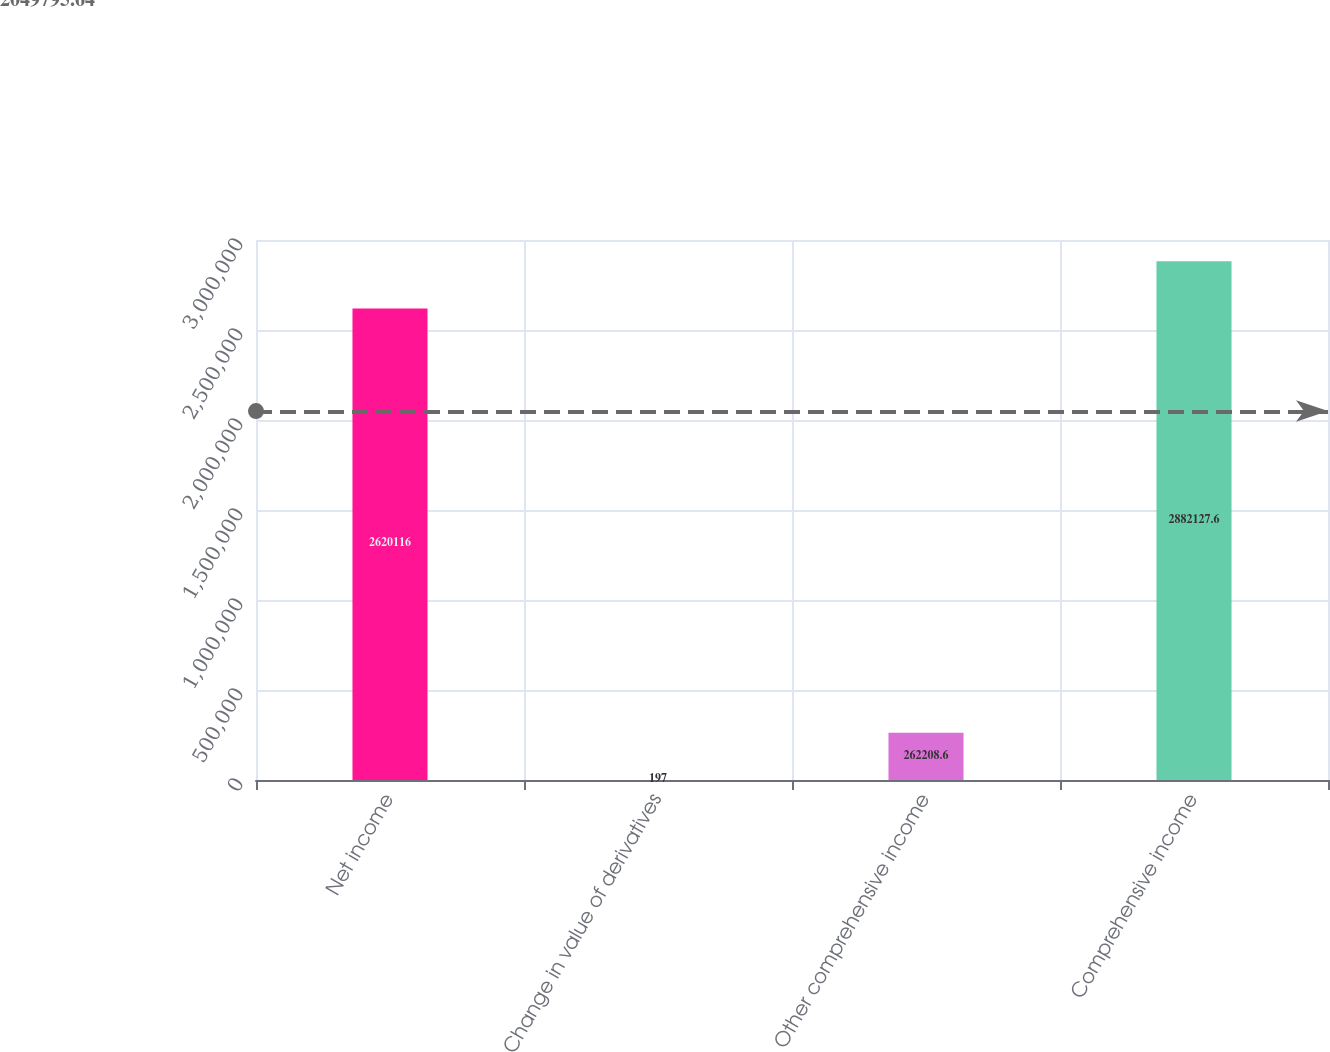<chart> <loc_0><loc_0><loc_500><loc_500><bar_chart><fcel>Net income<fcel>Change in value of derivatives<fcel>Other comprehensive income<fcel>Comprehensive income<nl><fcel>2.62012e+06<fcel>197<fcel>262209<fcel>2.88213e+06<nl></chart> 